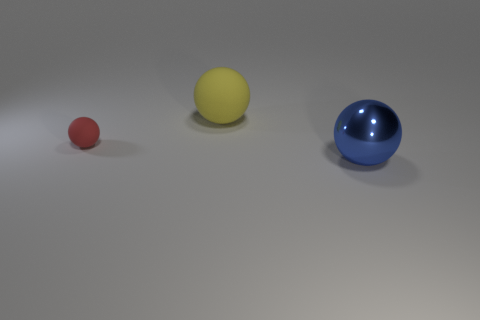What might be the context of this image? Are these balls used for any specific purpose? The image appears to be a simple, staged photo emphasizing the contrast in colors and sizes of spherical objects. It's unclear whether these balls serve a specific purpose beyond demonstration but they could perhaps be compared to objects such as sports equipment, toys, or artistic elements in a minimalist exhibit. 